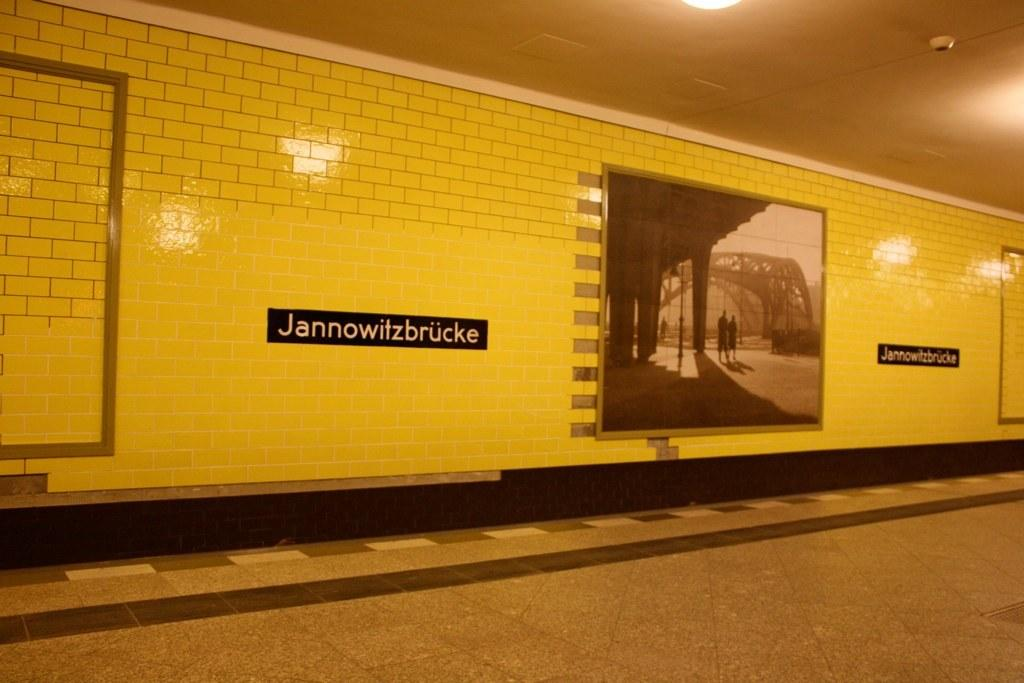What objects are present in the image that are used for displaying information or decoration? There are frames and name boards in the image. How are the frames and name boards attached to the surface in the image? The frames and name boards are attached to tiles in the image. Can you describe the lighting condition in the image? There is light in the image. What type of lock can be seen securing the branch in the image? There is no lock or branch present in the image; it only features frames, name boards, and tiles. 